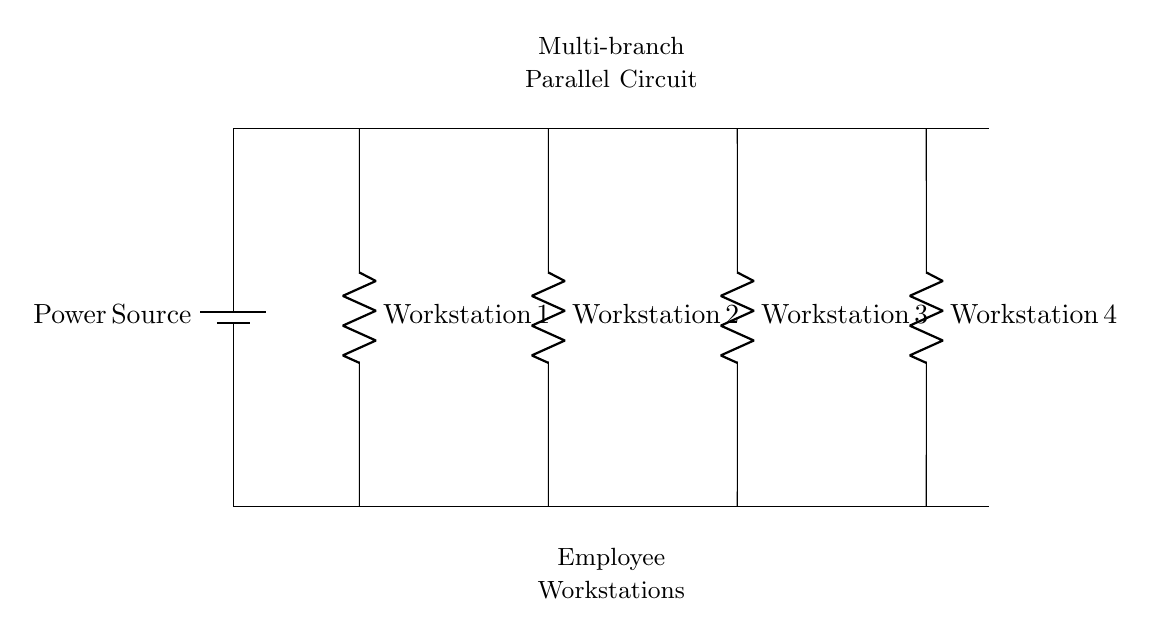What is the main purpose of this circuit? The main purpose of this circuit is to distribute electrical power from a single power source to multiple workstations simultaneously. Each workstation operates independently while connected to the same power supply.
Answer: Distributing power to workstations How many workstations are connected in this circuit? The circuit diagram clearly shows four distinct workstations, each connected in parallel to the power source along the main line.
Answer: Four What is the nature of the connection between the workstations and the power source? The connection is parallel, meaning each workstation is connected directly across the power source, allowing for each workstation to receive the same voltage while operating independently.
Answer: Parallel What type of component is used for each workstation? Each workstation in the circuit is represented by a resistor, indicating that they have some electrical resistance and consume power from the circuit.
Answer: Resistor If one workstation fails, what happens to the others? Since the workstations are arranged in parallel, if one workstation fails, the others will continue to operate without interruption as they are individually connected to the power source.
Answer: Others continue to operate What is the voltage across each workstation? The voltage across each workstation remains the same as that of the power source, as all are connected in parallel, allowing for equal voltage distribution.
Answer: Same as power source 